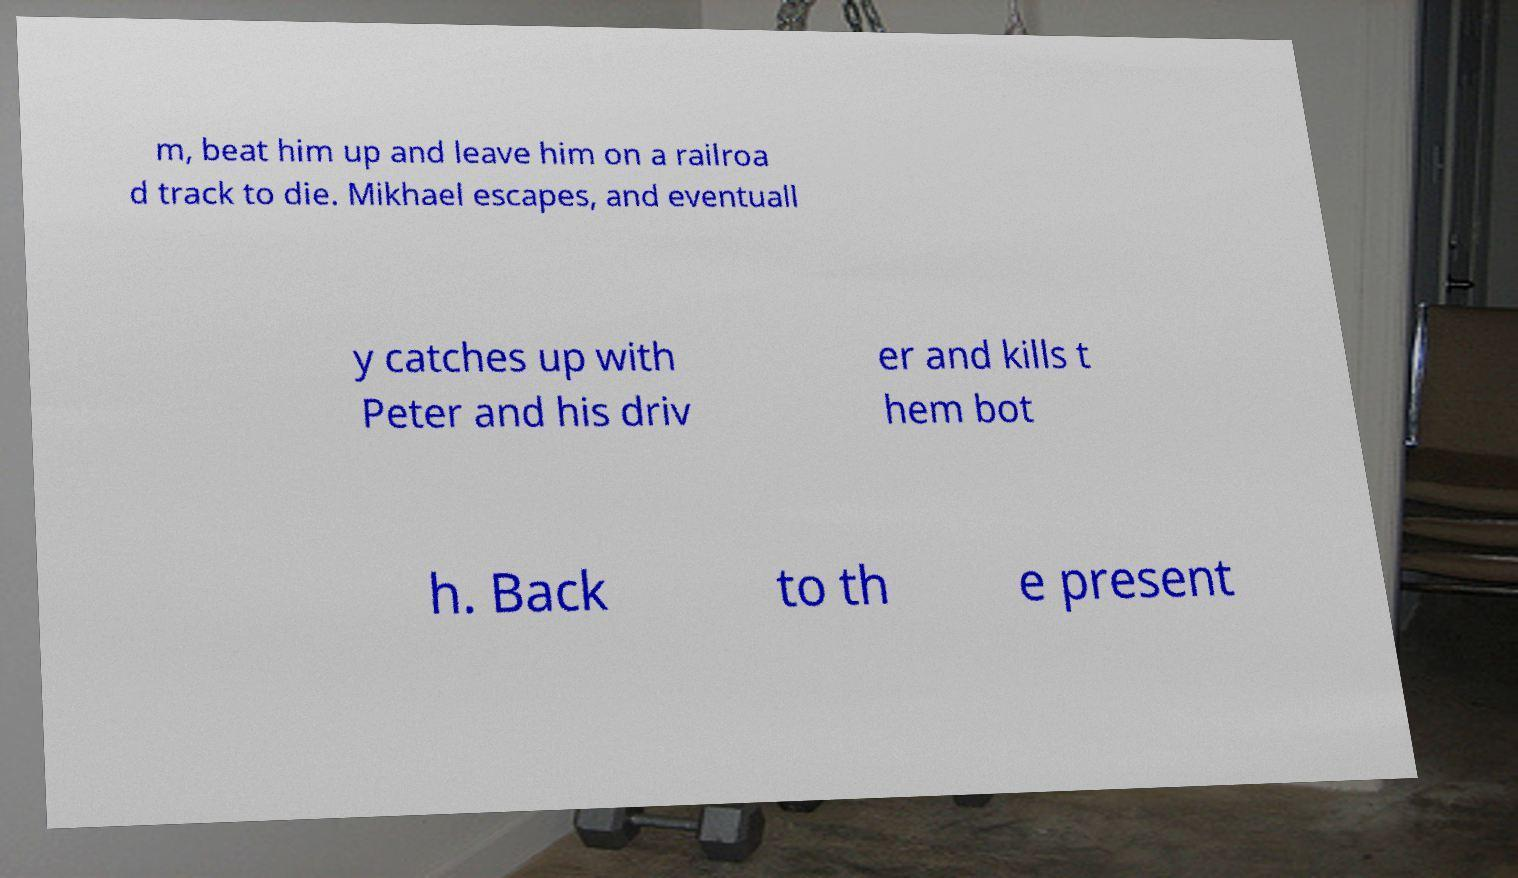There's text embedded in this image that I need extracted. Can you transcribe it verbatim? m, beat him up and leave him on a railroa d track to die. Mikhael escapes, and eventuall y catches up with Peter and his driv er and kills t hem bot h. Back to th e present 